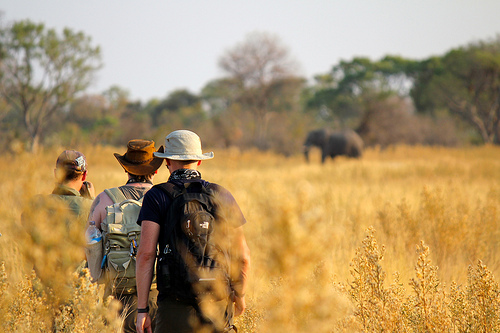What kind of hats are the men wearing? The men are wearing hats that appear to be suitable for outdoor activities. One man is wearing a wide-brimmed brown hat, another has a beige hat with a brim, and the third man is wearing a black cap with a neck cover. 